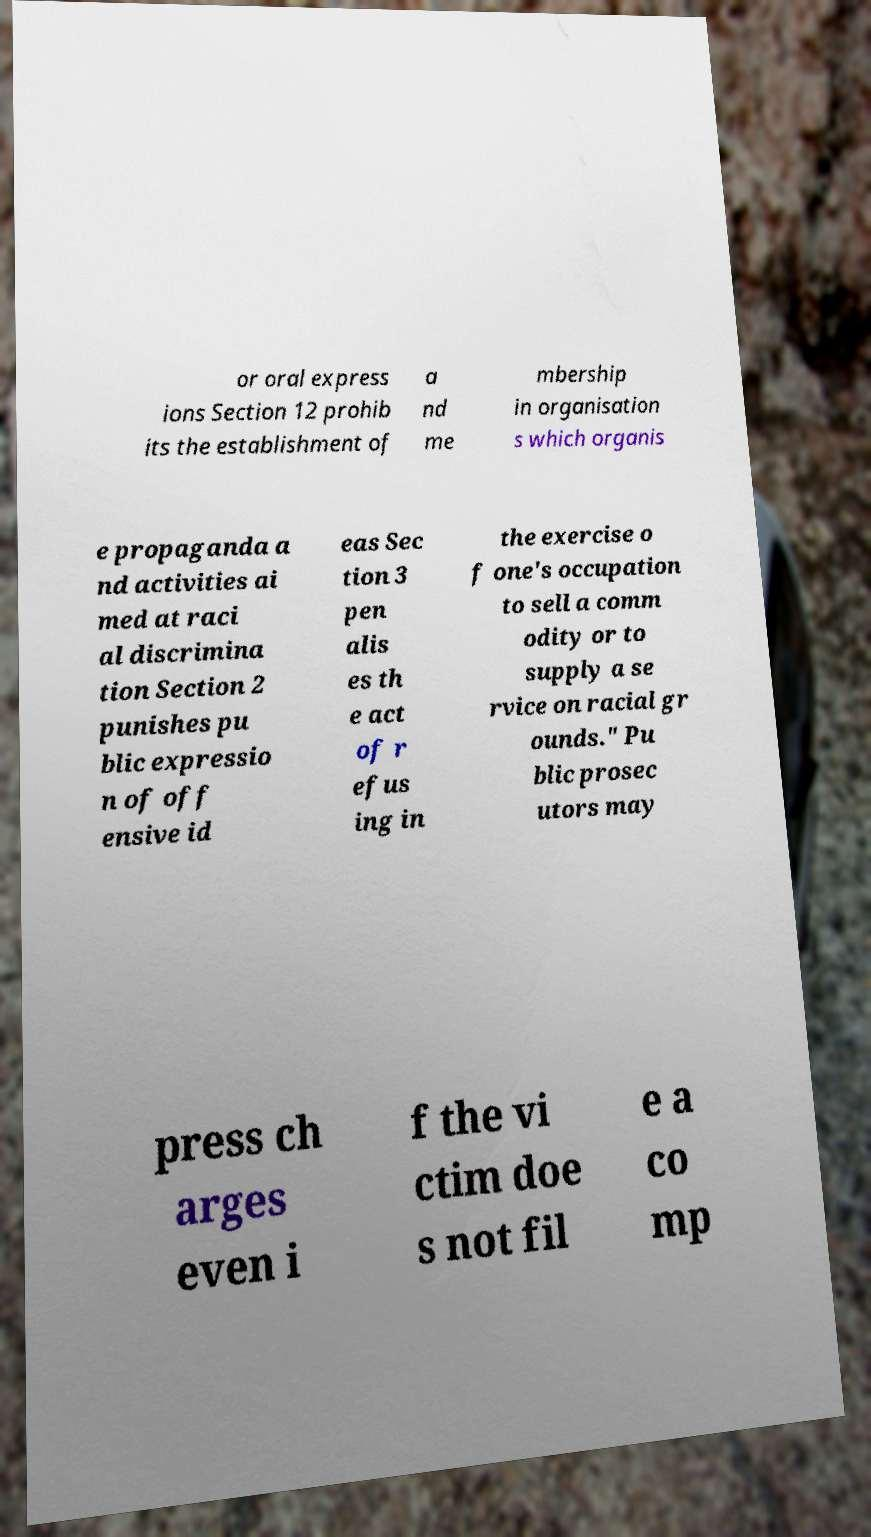Please read and relay the text visible in this image. What does it say? or oral express ions Section 12 prohib its the establishment of a nd me mbership in organisation s which organis e propaganda a nd activities ai med at raci al discrimina tion Section 2 punishes pu blic expressio n of off ensive id eas Sec tion 3 pen alis es th e act of r efus ing in the exercise o f one's occupation to sell a comm odity or to supply a se rvice on racial gr ounds." Pu blic prosec utors may press ch arges even i f the vi ctim doe s not fil e a co mp 